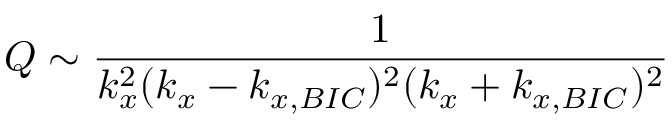Convert formula to latex. <formula><loc_0><loc_0><loc_500><loc_500>Q \sim \frac { 1 } { k _ { x } ^ { 2 } ( k _ { x } - k _ { x , B I C } ) ^ { 2 } ( k _ { x } + k _ { x , B I C } ) ^ { 2 } }</formula> 